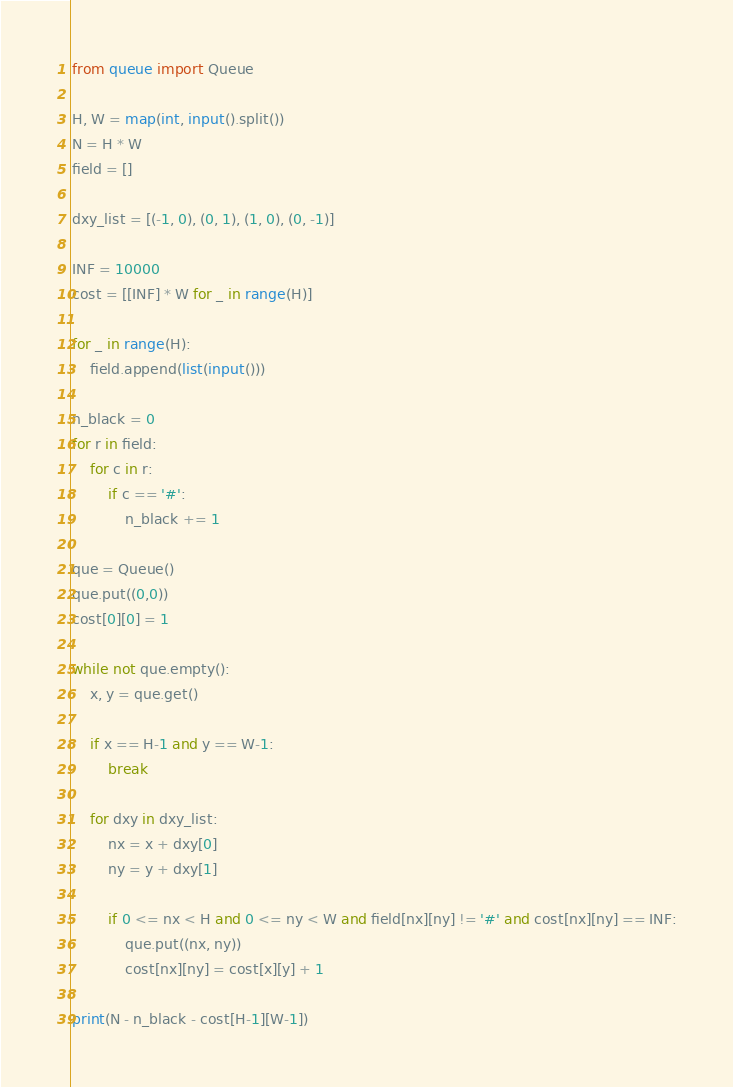<code> <loc_0><loc_0><loc_500><loc_500><_Python_>from queue import Queue

H, W = map(int, input().split())
N = H * W
field = []

dxy_list = [(-1, 0), (0, 1), (1, 0), (0, -1)]

INF = 10000
cost = [[INF] * W for _ in range(H)]

for _ in range(H):
    field.append(list(input()))

n_black = 0
for r in field:
    for c in r:
        if c == '#':
            n_black += 1

que = Queue()
que.put((0,0))
cost[0][0] = 1

while not que.empty():
    x, y = que.get()

    if x == H-1 and y == W-1:
        break

    for dxy in dxy_list:
        nx = x + dxy[0]
        ny = y + dxy[1]

        if 0 <= nx < H and 0 <= ny < W and field[nx][ny] != '#' and cost[nx][ny] == INF:
            que.put((nx, ny))
            cost[nx][ny] = cost[x][y] + 1    

print(N - n_black - cost[H-1][W-1])</code> 